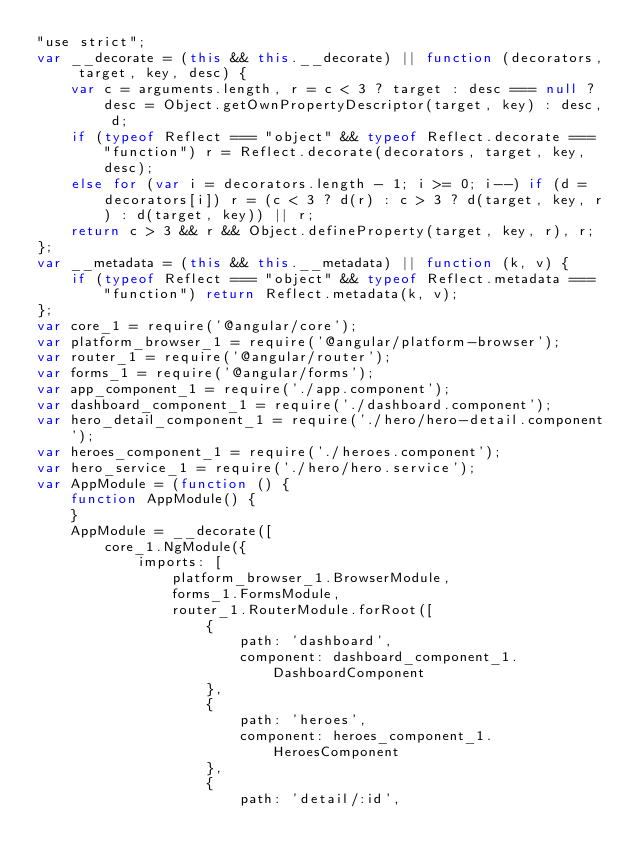Convert code to text. <code><loc_0><loc_0><loc_500><loc_500><_JavaScript_>"use strict";
var __decorate = (this && this.__decorate) || function (decorators, target, key, desc) {
    var c = arguments.length, r = c < 3 ? target : desc === null ? desc = Object.getOwnPropertyDescriptor(target, key) : desc, d;
    if (typeof Reflect === "object" && typeof Reflect.decorate === "function") r = Reflect.decorate(decorators, target, key, desc);
    else for (var i = decorators.length - 1; i >= 0; i--) if (d = decorators[i]) r = (c < 3 ? d(r) : c > 3 ? d(target, key, r) : d(target, key)) || r;
    return c > 3 && r && Object.defineProperty(target, key, r), r;
};
var __metadata = (this && this.__metadata) || function (k, v) {
    if (typeof Reflect === "object" && typeof Reflect.metadata === "function") return Reflect.metadata(k, v);
};
var core_1 = require('@angular/core');
var platform_browser_1 = require('@angular/platform-browser');
var router_1 = require('@angular/router');
var forms_1 = require('@angular/forms');
var app_component_1 = require('./app.component');
var dashboard_component_1 = require('./dashboard.component');
var hero_detail_component_1 = require('./hero/hero-detail.component');
var heroes_component_1 = require('./heroes.component');
var hero_service_1 = require('./hero/hero.service');
var AppModule = (function () {
    function AppModule() {
    }
    AppModule = __decorate([
        core_1.NgModule({
            imports: [
                platform_browser_1.BrowserModule,
                forms_1.FormsModule,
                router_1.RouterModule.forRoot([
                    {
                        path: 'dashboard',
                        component: dashboard_component_1.DashboardComponent
                    },
                    {
                        path: 'heroes',
                        component: heroes_component_1.HeroesComponent
                    },
                    {
                        path: 'detail/:id',</code> 